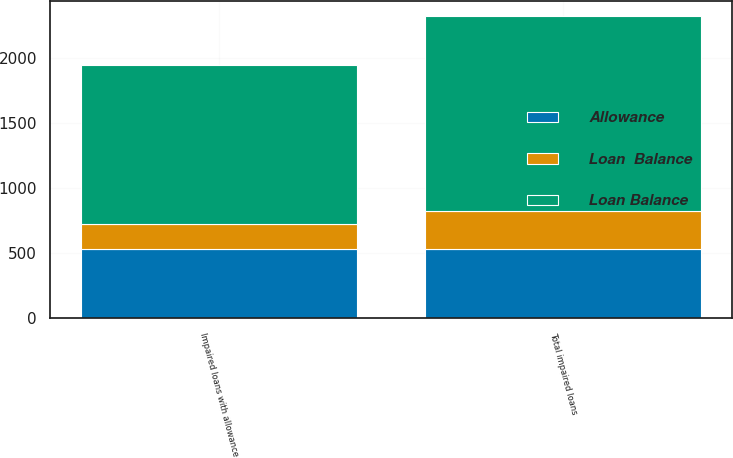<chart> <loc_0><loc_0><loc_500><loc_500><stacked_bar_chart><ecel><fcel>Impaired loans with allowance<fcel>Total impaired loans<nl><fcel>Loan Balance<fcel>1222<fcel>1492<nl><fcel>Allowance<fcel>534<fcel>534<nl><fcel>Loan  Balance<fcel>193<fcel>293<nl></chart> 